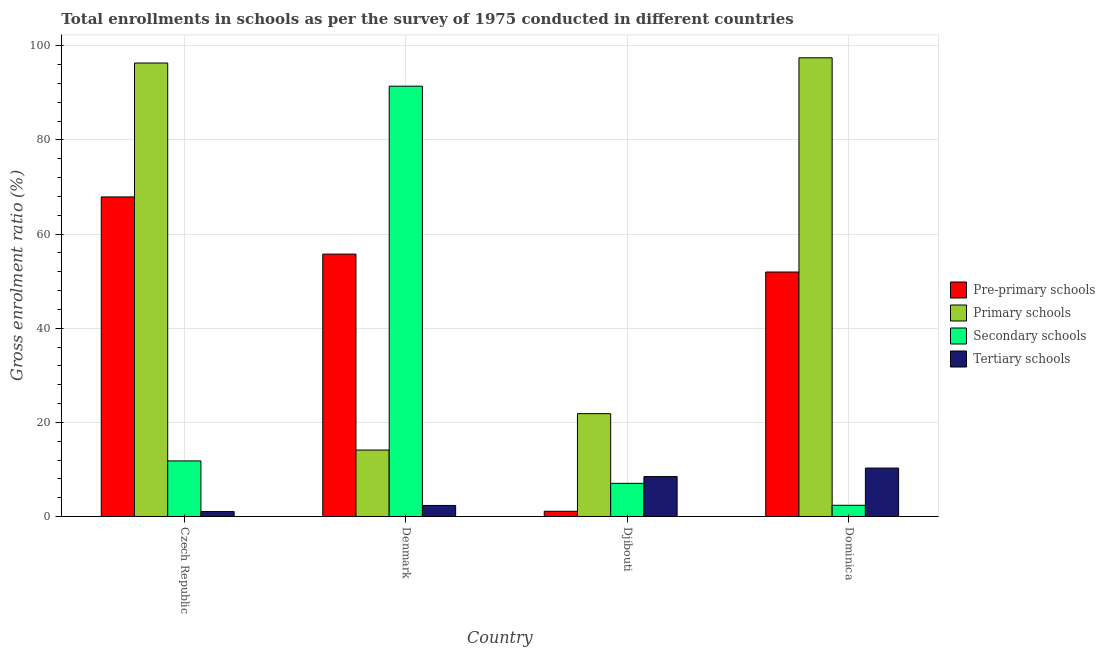Are the number of bars per tick equal to the number of legend labels?
Keep it short and to the point. Yes. Are the number of bars on each tick of the X-axis equal?
Provide a short and direct response. Yes. How many bars are there on the 2nd tick from the right?
Provide a short and direct response. 4. What is the label of the 3rd group of bars from the left?
Make the answer very short. Djibouti. In how many cases, is the number of bars for a given country not equal to the number of legend labels?
Your answer should be compact. 0. What is the gross enrolment ratio in secondary schools in Djibouti?
Keep it short and to the point. 7.04. Across all countries, what is the maximum gross enrolment ratio in pre-primary schools?
Ensure brevity in your answer.  67.9. Across all countries, what is the minimum gross enrolment ratio in secondary schools?
Provide a succinct answer. 2.38. In which country was the gross enrolment ratio in primary schools maximum?
Provide a succinct answer. Dominica. What is the total gross enrolment ratio in secondary schools in the graph?
Keep it short and to the point. 112.66. What is the difference between the gross enrolment ratio in pre-primary schools in Denmark and that in Dominica?
Make the answer very short. 3.81. What is the difference between the gross enrolment ratio in pre-primary schools in Denmark and the gross enrolment ratio in secondary schools in Dominica?
Your response must be concise. 53.37. What is the average gross enrolment ratio in tertiary schools per country?
Make the answer very short. 5.54. What is the difference between the gross enrolment ratio in pre-primary schools and gross enrolment ratio in secondary schools in Dominica?
Your answer should be very brief. 49.56. What is the ratio of the gross enrolment ratio in primary schools in Czech Republic to that in Dominica?
Your answer should be very brief. 0.99. Is the gross enrolment ratio in pre-primary schools in Czech Republic less than that in Denmark?
Offer a very short reply. No. What is the difference between the highest and the second highest gross enrolment ratio in primary schools?
Give a very brief answer. 1.1. What is the difference between the highest and the lowest gross enrolment ratio in secondary schools?
Your answer should be very brief. 89.05. In how many countries, is the gross enrolment ratio in pre-primary schools greater than the average gross enrolment ratio in pre-primary schools taken over all countries?
Make the answer very short. 3. Is the sum of the gross enrolment ratio in primary schools in Djibouti and Dominica greater than the maximum gross enrolment ratio in tertiary schools across all countries?
Your answer should be compact. Yes. Is it the case that in every country, the sum of the gross enrolment ratio in tertiary schools and gross enrolment ratio in secondary schools is greater than the sum of gross enrolment ratio in pre-primary schools and gross enrolment ratio in primary schools?
Your response must be concise. No. What does the 2nd bar from the left in Djibouti represents?
Provide a succinct answer. Primary schools. What does the 4th bar from the right in Djibouti represents?
Your answer should be very brief. Pre-primary schools. Is it the case that in every country, the sum of the gross enrolment ratio in pre-primary schools and gross enrolment ratio in primary schools is greater than the gross enrolment ratio in secondary schools?
Your response must be concise. No. How many countries are there in the graph?
Your answer should be compact. 4. Are the values on the major ticks of Y-axis written in scientific E-notation?
Give a very brief answer. No. Does the graph contain any zero values?
Keep it short and to the point. No. Does the graph contain grids?
Offer a terse response. Yes. Where does the legend appear in the graph?
Provide a short and direct response. Center right. How many legend labels are there?
Keep it short and to the point. 4. How are the legend labels stacked?
Ensure brevity in your answer.  Vertical. What is the title of the graph?
Provide a short and direct response. Total enrollments in schools as per the survey of 1975 conducted in different countries. What is the label or title of the X-axis?
Provide a succinct answer. Country. What is the label or title of the Y-axis?
Offer a terse response. Gross enrolment ratio (%). What is the Gross enrolment ratio (%) in Pre-primary schools in Czech Republic?
Provide a short and direct response. 67.9. What is the Gross enrolment ratio (%) in Primary schools in Czech Republic?
Provide a short and direct response. 96.35. What is the Gross enrolment ratio (%) of Secondary schools in Czech Republic?
Your answer should be compact. 11.81. What is the Gross enrolment ratio (%) of Tertiary schools in Czech Republic?
Offer a very short reply. 1.05. What is the Gross enrolment ratio (%) in Pre-primary schools in Denmark?
Keep it short and to the point. 55.75. What is the Gross enrolment ratio (%) in Primary schools in Denmark?
Your answer should be compact. 14.12. What is the Gross enrolment ratio (%) in Secondary schools in Denmark?
Your answer should be very brief. 91.43. What is the Gross enrolment ratio (%) in Tertiary schools in Denmark?
Make the answer very short. 2.34. What is the Gross enrolment ratio (%) in Pre-primary schools in Djibouti?
Give a very brief answer. 1.11. What is the Gross enrolment ratio (%) in Primary schools in Djibouti?
Offer a very short reply. 21.85. What is the Gross enrolment ratio (%) in Secondary schools in Djibouti?
Make the answer very short. 7.04. What is the Gross enrolment ratio (%) of Tertiary schools in Djibouti?
Give a very brief answer. 8.48. What is the Gross enrolment ratio (%) of Pre-primary schools in Dominica?
Offer a terse response. 51.94. What is the Gross enrolment ratio (%) of Primary schools in Dominica?
Make the answer very short. 97.46. What is the Gross enrolment ratio (%) of Secondary schools in Dominica?
Your response must be concise. 2.38. What is the Gross enrolment ratio (%) in Tertiary schools in Dominica?
Give a very brief answer. 10.29. Across all countries, what is the maximum Gross enrolment ratio (%) in Pre-primary schools?
Your answer should be compact. 67.9. Across all countries, what is the maximum Gross enrolment ratio (%) in Primary schools?
Keep it short and to the point. 97.46. Across all countries, what is the maximum Gross enrolment ratio (%) in Secondary schools?
Provide a succinct answer. 91.43. Across all countries, what is the maximum Gross enrolment ratio (%) in Tertiary schools?
Your answer should be very brief. 10.29. Across all countries, what is the minimum Gross enrolment ratio (%) of Pre-primary schools?
Give a very brief answer. 1.11. Across all countries, what is the minimum Gross enrolment ratio (%) of Primary schools?
Give a very brief answer. 14.12. Across all countries, what is the minimum Gross enrolment ratio (%) in Secondary schools?
Your answer should be very brief. 2.38. Across all countries, what is the minimum Gross enrolment ratio (%) in Tertiary schools?
Your response must be concise. 1.05. What is the total Gross enrolment ratio (%) of Pre-primary schools in the graph?
Offer a very short reply. 176.7. What is the total Gross enrolment ratio (%) of Primary schools in the graph?
Your answer should be compact. 229.77. What is the total Gross enrolment ratio (%) in Secondary schools in the graph?
Offer a terse response. 112.66. What is the total Gross enrolment ratio (%) of Tertiary schools in the graph?
Offer a terse response. 22.16. What is the difference between the Gross enrolment ratio (%) in Pre-primary schools in Czech Republic and that in Denmark?
Your answer should be very brief. 12.15. What is the difference between the Gross enrolment ratio (%) in Primary schools in Czech Republic and that in Denmark?
Give a very brief answer. 82.24. What is the difference between the Gross enrolment ratio (%) in Secondary schools in Czech Republic and that in Denmark?
Make the answer very short. -79.62. What is the difference between the Gross enrolment ratio (%) in Tertiary schools in Czech Republic and that in Denmark?
Your answer should be very brief. -1.3. What is the difference between the Gross enrolment ratio (%) in Pre-primary schools in Czech Republic and that in Djibouti?
Ensure brevity in your answer.  66.79. What is the difference between the Gross enrolment ratio (%) in Primary schools in Czech Republic and that in Djibouti?
Provide a short and direct response. 74.5. What is the difference between the Gross enrolment ratio (%) in Secondary schools in Czech Republic and that in Djibouti?
Offer a very short reply. 4.76. What is the difference between the Gross enrolment ratio (%) in Tertiary schools in Czech Republic and that in Djibouti?
Your answer should be very brief. -7.43. What is the difference between the Gross enrolment ratio (%) of Pre-primary schools in Czech Republic and that in Dominica?
Provide a short and direct response. 15.96. What is the difference between the Gross enrolment ratio (%) in Primary schools in Czech Republic and that in Dominica?
Your answer should be very brief. -1.1. What is the difference between the Gross enrolment ratio (%) in Secondary schools in Czech Republic and that in Dominica?
Your response must be concise. 9.43. What is the difference between the Gross enrolment ratio (%) in Tertiary schools in Czech Republic and that in Dominica?
Your answer should be compact. -9.24. What is the difference between the Gross enrolment ratio (%) of Pre-primary schools in Denmark and that in Djibouti?
Ensure brevity in your answer.  54.64. What is the difference between the Gross enrolment ratio (%) in Primary schools in Denmark and that in Djibouti?
Provide a short and direct response. -7.73. What is the difference between the Gross enrolment ratio (%) in Secondary schools in Denmark and that in Djibouti?
Keep it short and to the point. 84.38. What is the difference between the Gross enrolment ratio (%) in Tertiary schools in Denmark and that in Djibouti?
Provide a short and direct response. -6.14. What is the difference between the Gross enrolment ratio (%) in Pre-primary schools in Denmark and that in Dominica?
Offer a very short reply. 3.81. What is the difference between the Gross enrolment ratio (%) of Primary schools in Denmark and that in Dominica?
Offer a terse response. -83.34. What is the difference between the Gross enrolment ratio (%) in Secondary schools in Denmark and that in Dominica?
Ensure brevity in your answer.  89.05. What is the difference between the Gross enrolment ratio (%) in Tertiary schools in Denmark and that in Dominica?
Your answer should be compact. -7.95. What is the difference between the Gross enrolment ratio (%) in Pre-primary schools in Djibouti and that in Dominica?
Provide a succinct answer. -50.83. What is the difference between the Gross enrolment ratio (%) of Primary schools in Djibouti and that in Dominica?
Provide a succinct answer. -75.61. What is the difference between the Gross enrolment ratio (%) in Secondary schools in Djibouti and that in Dominica?
Offer a terse response. 4.66. What is the difference between the Gross enrolment ratio (%) of Tertiary schools in Djibouti and that in Dominica?
Your answer should be very brief. -1.81. What is the difference between the Gross enrolment ratio (%) of Pre-primary schools in Czech Republic and the Gross enrolment ratio (%) of Primary schools in Denmark?
Ensure brevity in your answer.  53.78. What is the difference between the Gross enrolment ratio (%) of Pre-primary schools in Czech Republic and the Gross enrolment ratio (%) of Secondary schools in Denmark?
Keep it short and to the point. -23.53. What is the difference between the Gross enrolment ratio (%) in Pre-primary schools in Czech Republic and the Gross enrolment ratio (%) in Tertiary schools in Denmark?
Give a very brief answer. 65.55. What is the difference between the Gross enrolment ratio (%) of Primary schools in Czech Republic and the Gross enrolment ratio (%) of Secondary schools in Denmark?
Provide a succinct answer. 4.93. What is the difference between the Gross enrolment ratio (%) in Primary schools in Czech Republic and the Gross enrolment ratio (%) in Tertiary schools in Denmark?
Give a very brief answer. 94.01. What is the difference between the Gross enrolment ratio (%) in Secondary schools in Czech Republic and the Gross enrolment ratio (%) in Tertiary schools in Denmark?
Offer a very short reply. 9.47. What is the difference between the Gross enrolment ratio (%) in Pre-primary schools in Czech Republic and the Gross enrolment ratio (%) in Primary schools in Djibouti?
Make the answer very short. 46.05. What is the difference between the Gross enrolment ratio (%) in Pre-primary schools in Czech Republic and the Gross enrolment ratio (%) in Secondary schools in Djibouti?
Ensure brevity in your answer.  60.85. What is the difference between the Gross enrolment ratio (%) of Pre-primary schools in Czech Republic and the Gross enrolment ratio (%) of Tertiary schools in Djibouti?
Your answer should be very brief. 59.42. What is the difference between the Gross enrolment ratio (%) of Primary schools in Czech Republic and the Gross enrolment ratio (%) of Secondary schools in Djibouti?
Make the answer very short. 89.31. What is the difference between the Gross enrolment ratio (%) in Primary schools in Czech Republic and the Gross enrolment ratio (%) in Tertiary schools in Djibouti?
Keep it short and to the point. 87.87. What is the difference between the Gross enrolment ratio (%) of Secondary schools in Czech Republic and the Gross enrolment ratio (%) of Tertiary schools in Djibouti?
Keep it short and to the point. 3.33. What is the difference between the Gross enrolment ratio (%) in Pre-primary schools in Czech Republic and the Gross enrolment ratio (%) in Primary schools in Dominica?
Ensure brevity in your answer.  -29.56. What is the difference between the Gross enrolment ratio (%) of Pre-primary schools in Czech Republic and the Gross enrolment ratio (%) of Secondary schools in Dominica?
Provide a succinct answer. 65.52. What is the difference between the Gross enrolment ratio (%) in Pre-primary schools in Czech Republic and the Gross enrolment ratio (%) in Tertiary schools in Dominica?
Offer a terse response. 57.61. What is the difference between the Gross enrolment ratio (%) in Primary schools in Czech Republic and the Gross enrolment ratio (%) in Secondary schools in Dominica?
Offer a very short reply. 93.97. What is the difference between the Gross enrolment ratio (%) in Primary schools in Czech Republic and the Gross enrolment ratio (%) in Tertiary schools in Dominica?
Your answer should be very brief. 86.06. What is the difference between the Gross enrolment ratio (%) of Secondary schools in Czech Republic and the Gross enrolment ratio (%) of Tertiary schools in Dominica?
Ensure brevity in your answer.  1.52. What is the difference between the Gross enrolment ratio (%) of Pre-primary schools in Denmark and the Gross enrolment ratio (%) of Primary schools in Djibouti?
Your answer should be compact. 33.9. What is the difference between the Gross enrolment ratio (%) of Pre-primary schools in Denmark and the Gross enrolment ratio (%) of Secondary schools in Djibouti?
Your response must be concise. 48.71. What is the difference between the Gross enrolment ratio (%) in Pre-primary schools in Denmark and the Gross enrolment ratio (%) in Tertiary schools in Djibouti?
Provide a short and direct response. 47.27. What is the difference between the Gross enrolment ratio (%) of Primary schools in Denmark and the Gross enrolment ratio (%) of Secondary schools in Djibouti?
Ensure brevity in your answer.  7.07. What is the difference between the Gross enrolment ratio (%) in Primary schools in Denmark and the Gross enrolment ratio (%) in Tertiary schools in Djibouti?
Your answer should be compact. 5.64. What is the difference between the Gross enrolment ratio (%) in Secondary schools in Denmark and the Gross enrolment ratio (%) in Tertiary schools in Djibouti?
Provide a succinct answer. 82.95. What is the difference between the Gross enrolment ratio (%) in Pre-primary schools in Denmark and the Gross enrolment ratio (%) in Primary schools in Dominica?
Make the answer very short. -41.71. What is the difference between the Gross enrolment ratio (%) in Pre-primary schools in Denmark and the Gross enrolment ratio (%) in Secondary schools in Dominica?
Provide a short and direct response. 53.37. What is the difference between the Gross enrolment ratio (%) in Pre-primary schools in Denmark and the Gross enrolment ratio (%) in Tertiary schools in Dominica?
Provide a short and direct response. 45.46. What is the difference between the Gross enrolment ratio (%) in Primary schools in Denmark and the Gross enrolment ratio (%) in Secondary schools in Dominica?
Ensure brevity in your answer.  11.74. What is the difference between the Gross enrolment ratio (%) of Primary schools in Denmark and the Gross enrolment ratio (%) of Tertiary schools in Dominica?
Ensure brevity in your answer.  3.83. What is the difference between the Gross enrolment ratio (%) in Secondary schools in Denmark and the Gross enrolment ratio (%) in Tertiary schools in Dominica?
Your answer should be compact. 81.14. What is the difference between the Gross enrolment ratio (%) in Pre-primary schools in Djibouti and the Gross enrolment ratio (%) in Primary schools in Dominica?
Keep it short and to the point. -96.35. What is the difference between the Gross enrolment ratio (%) in Pre-primary schools in Djibouti and the Gross enrolment ratio (%) in Secondary schools in Dominica?
Offer a terse response. -1.27. What is the difference between the Gross enrolment ratio (%) of Pre-primary schools in Djibouti and the Gross enrolment ratio (%) of Tertiary schools in Dominica?
Your response must be concise. -9.18. What is the difference between the Gross enrolment ratio (%) in Primary schools in Djibouti and the Gross enrolment ratio (%) in Secondary schools in Dominica?
Keep it short and to the point. 19.47. What is the difference between the Gross enrolment ratio (%) of Primary schools in Djibouti and the Gross enrolment ratio (%) of Tertiary schools in Dominica?
Provide a short and direct response. 11.56. What is the difference between the Gross enrolment ratio (%) in Secondary schools in Djibouti and the Gross enrolment ratio (%) in Tertiary schools in Dominica?
Your response must be concise. -3.25. What is the average Gross enrolment ratio (%) of Pre-primary schools per country?
Offer a terse response. 44.17. What is the average Gross enrolment ratio (%) of Primary schools per country?
Give a very brief answer. 57.44. What is the average Gross enrolment ratio (%) of Secondary schools per country?
Provide a short and direct response. 28.16. What is the average Gross enrolment ratio (%) in Tertiary schools per country?
Make the answer very short. 5.54. What is the difference between the Gross enrolment ratio (%) of Pre-primary schools and Gross enrolment ratio (%) of Primary schools in Czech Republic?
Ensure brevity in your answer.  -28.46. What is the difference between the Gross enrolment ratio (%) of Pre-primary schools and Gross enrolment ratio (%) of Secondary schools in Czech Republic?
Make the answer very short. 56.09. What is the difference between the Gross enrolment ratio (%) of Pre-primary schools and Gross enrolment ratio (%) of Tertiary schools in Czech Republic?
Give a very brief answer. 66.85. What is the difference between the Gross enrolment ratio (%) of Primary schools and Gross enrolment ratio (%) of Secondary schools in Czech Republic?
Ensure brevity in your answer.  84.55. What is the difference between the Gross enrolment ratio (%) in Primary schools and Gross enrolment ratio (%) in Tertiary schools in Czech Republic?
Your answer should be very brief. 95.31. What is the difference between the Gross enrolment ratio (%) in Secondary schools and Gross enrolment ratio (%) in Tertiary schools in Czech Republic?
Your response must be concise. 10.76. What is the difference between the Gross enrolment ratio (%) in Pre-primary schools and Gross enrolment ratio (%) in Primary schools in Denmark?
Keep it short and to the point. 41.63. What is the difference between the Gross enrolment ratio (%) in Pre-primary schools and Gross enrolment ratio (%) in Secondary schools in Denmark?
Ensure brevity in your answer.  -35.68. What is the difference between the Gross enrolment ratio (%) of Pre-primary schools and Gross enrolment ratio (%) of Tertiary schools in Denmark?
Provide a short and direct response. 53.41. What is the difference between the Gross enrolment ratio (%) of Primary schools and Gross enrolment ratio (%) of Secondary schools in Denmark?
Make the answer very short. -77.31. What is the difference between the Gross enrolment ratio (%) of Primary schools and Gross enrolment ratio (%) of Tertiary schools in Denmark?
Keep it short and to the point. 11.78. What is the difference between the Gross enrolment ratio (%) in Secondary schools and Gross enrolment ratio (%) in Tertiary schools in Denmark?
Your answer should be compact. 89.09. What is the difference between the Gross enrolment ratio (%) of Pre-primary schools and Gross enrolment ratio (%) of Primary schools in Djibouti?
Your answer should be very brief. -20.74. What is the difference between the Gross enrolment ratio (%) in Pre-primary schools and Gross enrolment ratio (%) in Secondary schools in Djibouti?
Ensure brevity in your answer.  -5.94. What is the difference between the Gross enrolment ratio (%) of Pre-primary schools and Gross enrolment ratio (%) of Tertiary schools in Djibouti?
Ensure brevity in your answer.  -7.37. What is the difference between the Gross enrolment ratio (%) in Primary schools and Gross enrolment ratio (%) in Secondary schools in Djibouti?
Your answer should be very brief. 14.8. What is the difference between the Gross enrolment ratio (%) in Primary schools and Gross enrolment ratio (%) in Tertiary schools in Djibouti?
Make the answer very short. 13.37. What is the difference between the Gross enrolment ratio (%) in Secondary schools and Gross enrolment ratio (%) in Tertiary schools in Djibouti?
Give a very brief answer. -1.44. What is the difference between the Gross enrolment ratio (%) of Pre-primary schools and Gross enrolment ratio (%) of Primary schools in Dominica?
Provide a short and direct response. -45.52. What is the difference between the Gross enrolment ratio (%) in Pre-primary schools and Gross enrolment ratio (%) in Secondary schools in Dominica?
Ensure brevity in your answer.  49.56. What is the difference between the Gross enrolment ratio (%) in Pre-primary schools and Gross enrolment ratio (%) in Tertiary schools in Dominica?
Keep it short and to the point. 41.65. What is the difference between the Gross enrolment ratio (%) in Primary schools and Gross enrolment ratio (%) in Secondary schools in Dominica?
Provide a short and direct response. 95.08. What is the difference between the Gross enrolment ratio (%) in Primary schools and Gross enrolment ratio (%) in Tertiary schools in Dominica?
Give a very brief answer. 87.16. What is the difference between the Gross enrolment ratio (%) in Secondary schools and Gross enrolment ratio (%) in Tertiary schools in Dominica?
Provide a short and direct response. -7.91. What is the ratio of the Gross enrolment ratio (%) in Pre-primary schools in Czech Republic to that in Denmark?
Your answer should be compact. 1.22. What is the ratio of the Gross enrolment ratio (%) of Primary schools in Czech Republic to that in Denmark?
Give a very brief answer. 6.83. What is the ratio of the Gross enrolment ratio (%) in Secondary schools in Czech Republic to that in Denmark?
Give a very brief answer. 0.13. What is the ratio of the Gross enrolment ratio (%) in Tertiary schools in Czech Republic to that in Denmark?
Give a very brief answer. 0.45. What is the ratio of the Gross enrolment ratio (%) in Pre-primary schools in Czech Republic to that in Djibouti?
Make the answer very short. 61.2. What is the ratio of the Gross enrolment ratio (%) of Primary schools in Czech Republic to that in Djibouti?
Keep it short and to the point. 4.41. What is the ratio of the Gross enrolment ratio (%) in Secondary schools in Czech Republic to that in Djibouti?
Offer a very short reply. 1.68. What is the ratio of the Gross enrolment ratio (%) of Tertiary schools in Czech Republic to that in Djibouti?
Your answer should be compact. 0.12. What is the ratio of the Gross enrolment ratio (%) of Pre-primary schools in Czech Republic to that in Dominica?
Provide a short and direct response. 1.31. What is the ratio of the Gross enrolment ratio (%) in Primary schools in Czech Republic to that in Dominica?
Give a very brief answer. 0.99. What is the ratio of the Gross enrolment ratio (%) of Secondary schools in Czech Republic to that in Dominica?
Provide a short and direct response. 4.96. What is the ratio of the Gross enrolment ratio (%) of Tertiary schools in Czech Republic to that in Dominica?
Your answer should be very brief. 0.1. What is the ratio of the Gross enrolment ratio (%) of Pre-primary schools in Denmark to that in Djibouti?
Offer a very short reply. 50.25. What is the ratio of the Gross enrolment ratio (%) of Primary schools in Denmark to that in Djibouti?
Ensure brevity in your answer.  0.65. What is the ratio of the Gross enrolment ratio (%) in Secondary schools in Denmark to that in Djibouti?
Offer a terse response. 12.98. What is the ratio of the Gross enrolment ratio (%) of Tertiary schools in Denmark to that in Djibouti?
Make the answer very short. 0.28. What is the ratio of the Gross enrolment ratio (%) in Pre-primary schools in Denmark to that in Dominica?
Make the answer very short. 1.07. What is the ratio of the Gross enrolment ratio (%) of Primary schools in Denmark to that in Dominica?
Ensure brevity in your answer.  0.14. What is the ratio of the Gross enrolment ratio (%) in Secondary schools in Denmark to that in Dominica?
Give a very brief answer. 38.41. What is the ratio of the Gross enrolment ratio (%) in Tertiary schools in Denmark to that in Dominica?
Ensure brevity in your answer.  0.23. What is the ratio of the Gross enrolment ratio (%) in Pre-primary schools in Djibouti to that in Dominica?
Your answer should be very brief. 0.02. What is the ratio of the Gross enrolment ratio (%) of Primary schools in Djibouti to that in Dominica?
Keep it short and to the point. 0.22. What is the ratio of the Gross enrolment ratio (%) of Secondary schools in Djibouti to that in Dominica?
Give a very brief answer. 2.96. What is the ratio of the Gross enrolment ratio (%) in Tertiary schools in Djibouti to that in Dominica?
Provide a succinct answer. 0.82. What is the difference between the highest and the second highest Gross enrolment ratio (%) in Pre-primary schools?
Your response must be concise. 12.15. What is the difference between the highest and the second highest Gross enrolment ratio (%) in Primary schools?
Offer a terse response. 1.1. What is the difference between the highest and the second highest Gross enrolment ratio (%) in Secondary schools?
Offer a very short reply. 79.62. What is the difference between the highest and the second highest Gross enrolment ratio (%) in Tertiary schools?
Offer a very short reply. 1.81. What is the difference between the highest and the lowest Gross enrolment ratio (%) in Pre-primary schools?
Provide a short and direct response. 66.79. What is the difference between the highest and the lowest Gross enrolment ratio (%) in Primary schools?
Provide a succinct answer. 83.34. What is the difference between the highest and the lowest Gross enrolment ratio (%) of Secondary schools?
Keep it short and to the point. 89.05. What is the difference between the highest and the lowest Gross enrolment ratio (%) in Tertiary schools?
Provide a short and direct response. 9.24. 